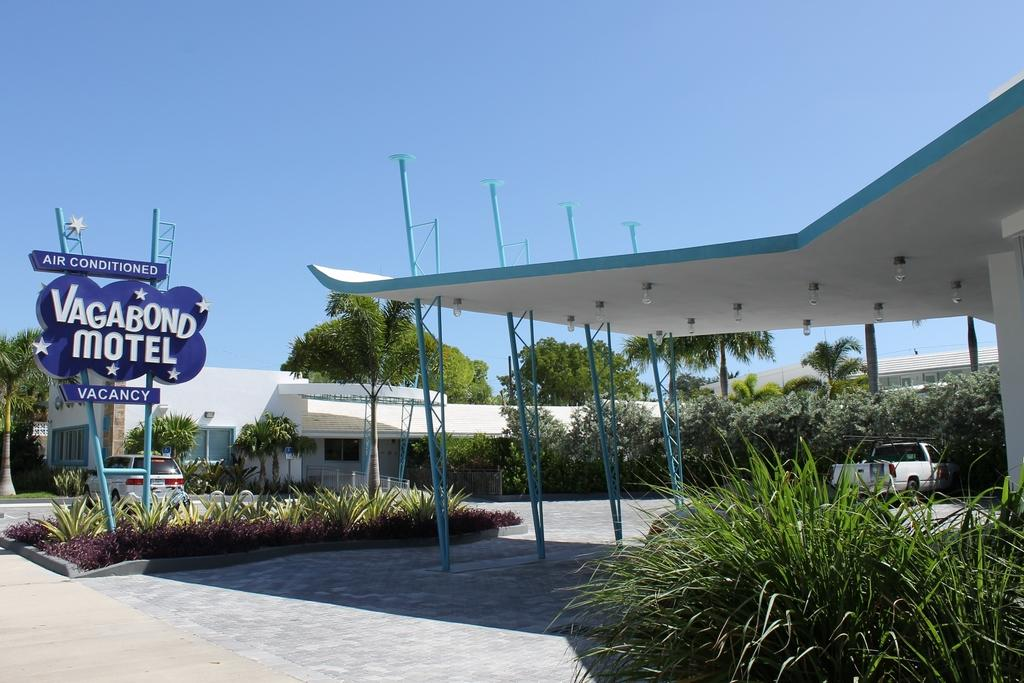Provide a one-sentence caption for the provided image. Vagabond Motel with air conditioned and a white truck parked there. 